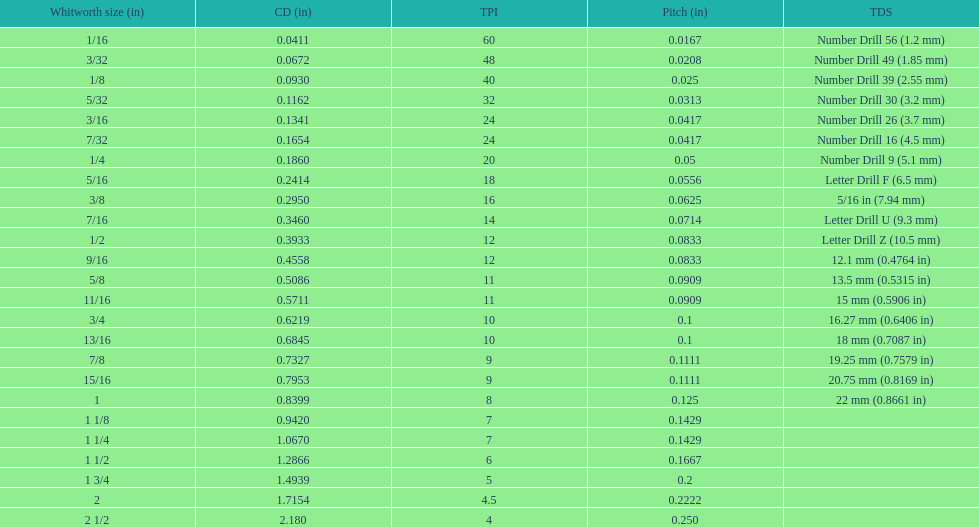Which whitworth size has the same number of threads per inch as 3/16? 7/32. 